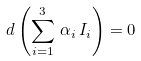<formula> <loc_0><loc_0><loc_500><loc_500>d \left ( \sum _ { i = 1 } ^ { 3 } \, \alpha _ { i } \, I _ { i } \right ) = 0</formula> 